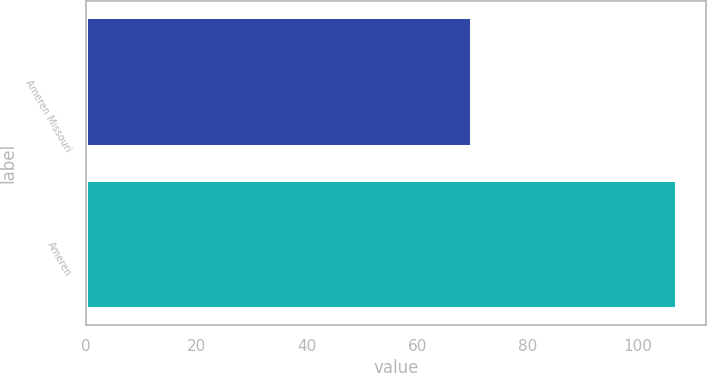<chart> <loc_0><loc_0><loc_500><loc_500><bar_chart><fcel>Ameren Missouri<fcel>Ameren<nl><fcel>70<fcel>107<nl></chart> 